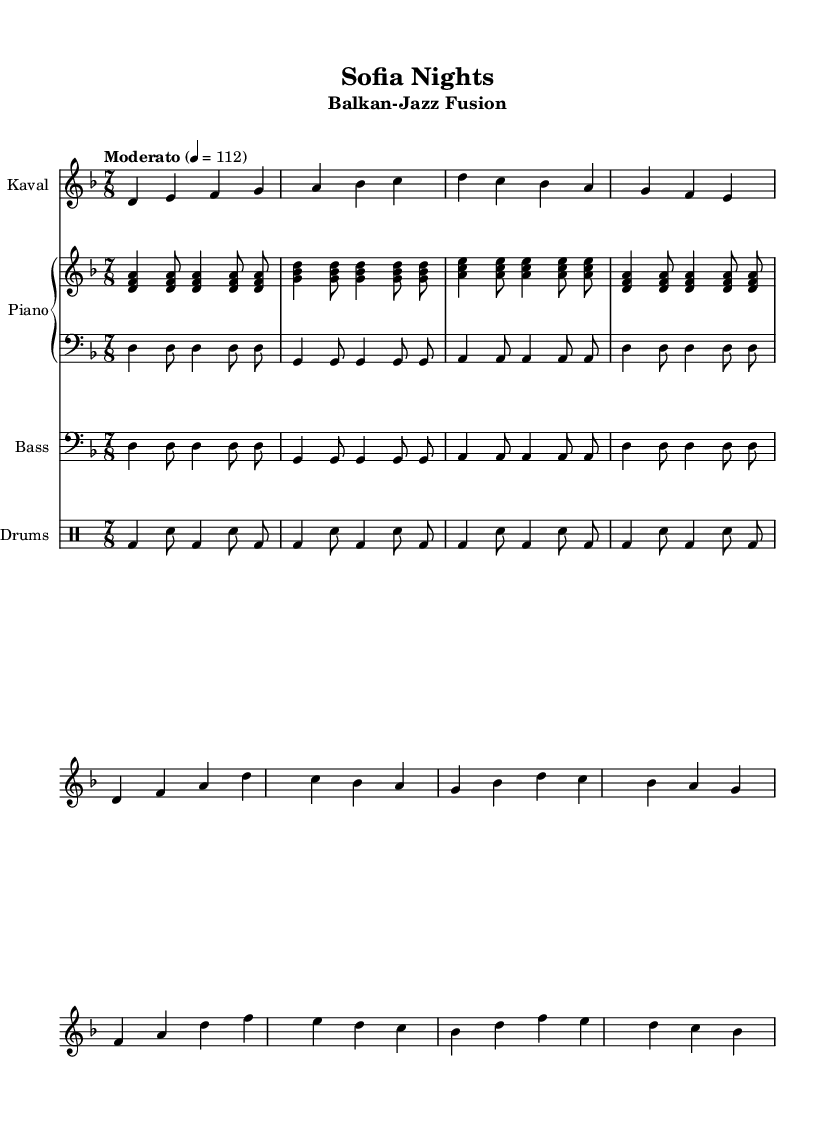What is the key signature of this music? The key signature is indicated at the beginning of the score, showing two flats (B♭ and E♭), which corresponds to D minor.
Answer: D minor What is the time signature of this music? The time signature is shown at the beginning of the score as 7/8, meaning there are seven eighth notes in each measure.
Answer: 7/8 What is the tempo marking for this piece? The tempo marking states "Moderato" with a metronome marking of 112 beats per minute, indicating a moderately fast pace.
Answer: Moderato 112 How many measures are there in the kaval part? By counting the individual measures in the kaval section, there are a total of eight measures present.
Answer: 8 What is the role of the drums in this fusion piece? The drums provide a rhythmic foundation and accompany the other instruments, adding energy through the pattern of bass drum and snare hits in the score.
Answer: Rhythmic foundation Which instruments are used in this composition? The sheet music lists four distinct parts: Kaval, Piano, Bass, and Drums, showcasing a blend of traditional and modern instrumentation.
Answer: Kaval, Piano, Bass, Drums What type of musical fusion is represented in this piece? The title and subtitle indicate that it is a Balkan-Jazz fusion, blending traditional Bulgarian folk melodies with jazz harmonies and rhythms.
Answer: Balkan-Jazz fusion 